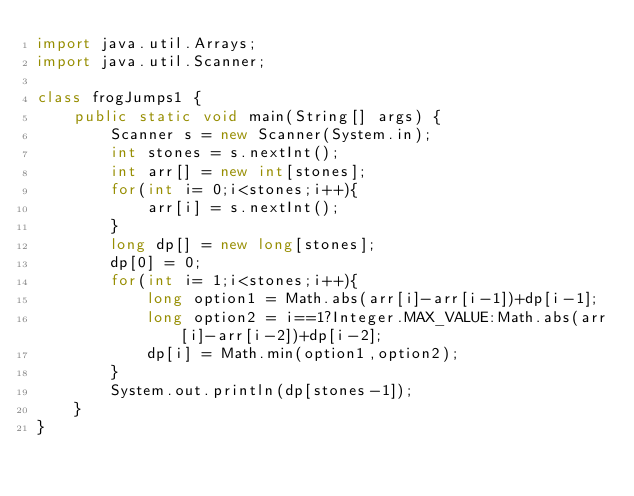<code> <loc_0><loc_0><loc_500><loc_500><_Java_>import java.util.Arrays;
import java.util.Scanner;

class frogJumps1 {
    public static void main(String[] args) {
        Scanner s = new Scanner(System.in);
        int stones = s.nextInt();
        int arr[] = new int[stones];
        for(int i= 0;i<stones;i++){
            arr[i] = s.nextInt();
        }
        long dp[] = new long[stones];
        dp[0] = 0;
        for(int i= 1;i<stones;i++){
            long option1 = Math.abs(arr[i]-arr[i-1])+dp[i-1];
            long option2 = i==1?Integer.MAX_VALUE:Math.abs(arr[i]-arr[i-2])+dp[i-2];
            dp[i] = Math.min(option1,option2);
        }
        System.out.println(dp[stones-1]);
    }
}
</code> 